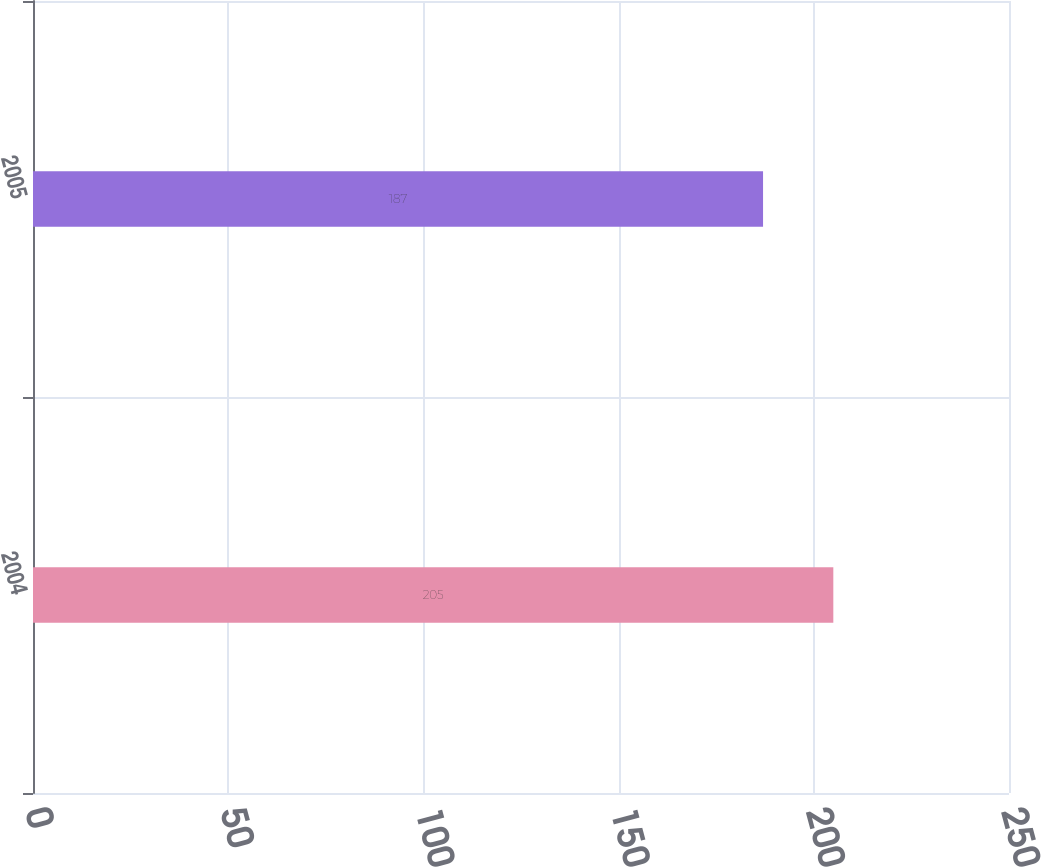Convert chart. <chart><loc_0><loc_0><loc_500><loc_500><bar_chart><fcel>2004<fcel>2005<nl><fcel>205<fcel>187<nl></chart> 